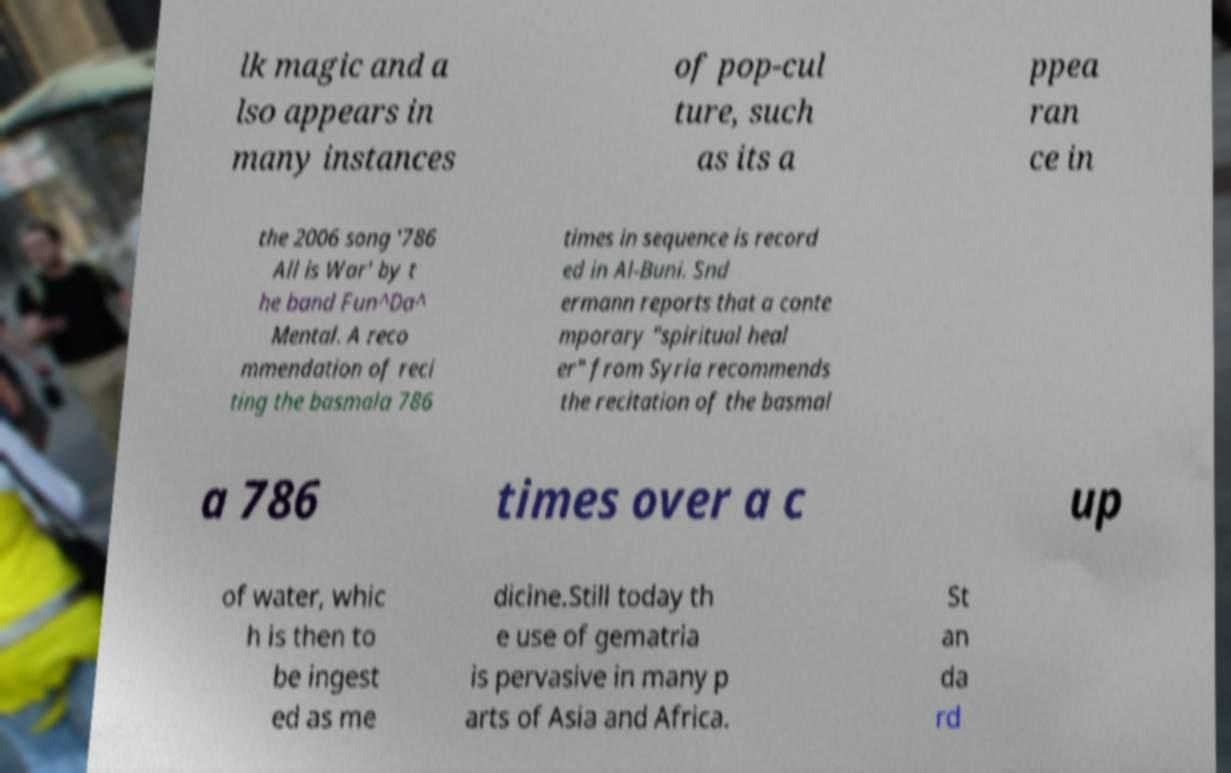There's text embedded in this image that I need extracted. Can you transcribe it verbatim? lk magic and a lso appears in many instances of pop-cul ture, such as its a ppea ran ce in the 2006 song '786 All is War' by t he band Fun^Da^ Mental. A reco mmendation of reci ting the basmala 786 times in sequence is record ed in Al-Buni. Snd ermann reports that a conte mporary "spiritual heal er" from Syria recommends the recitation of the basmal a 786 times over a c up of water, whic h is then to be ingest ed as me dicine.Still today th e use of gematria is pervasive in many p arts of Asia and Africa. St an da rd 